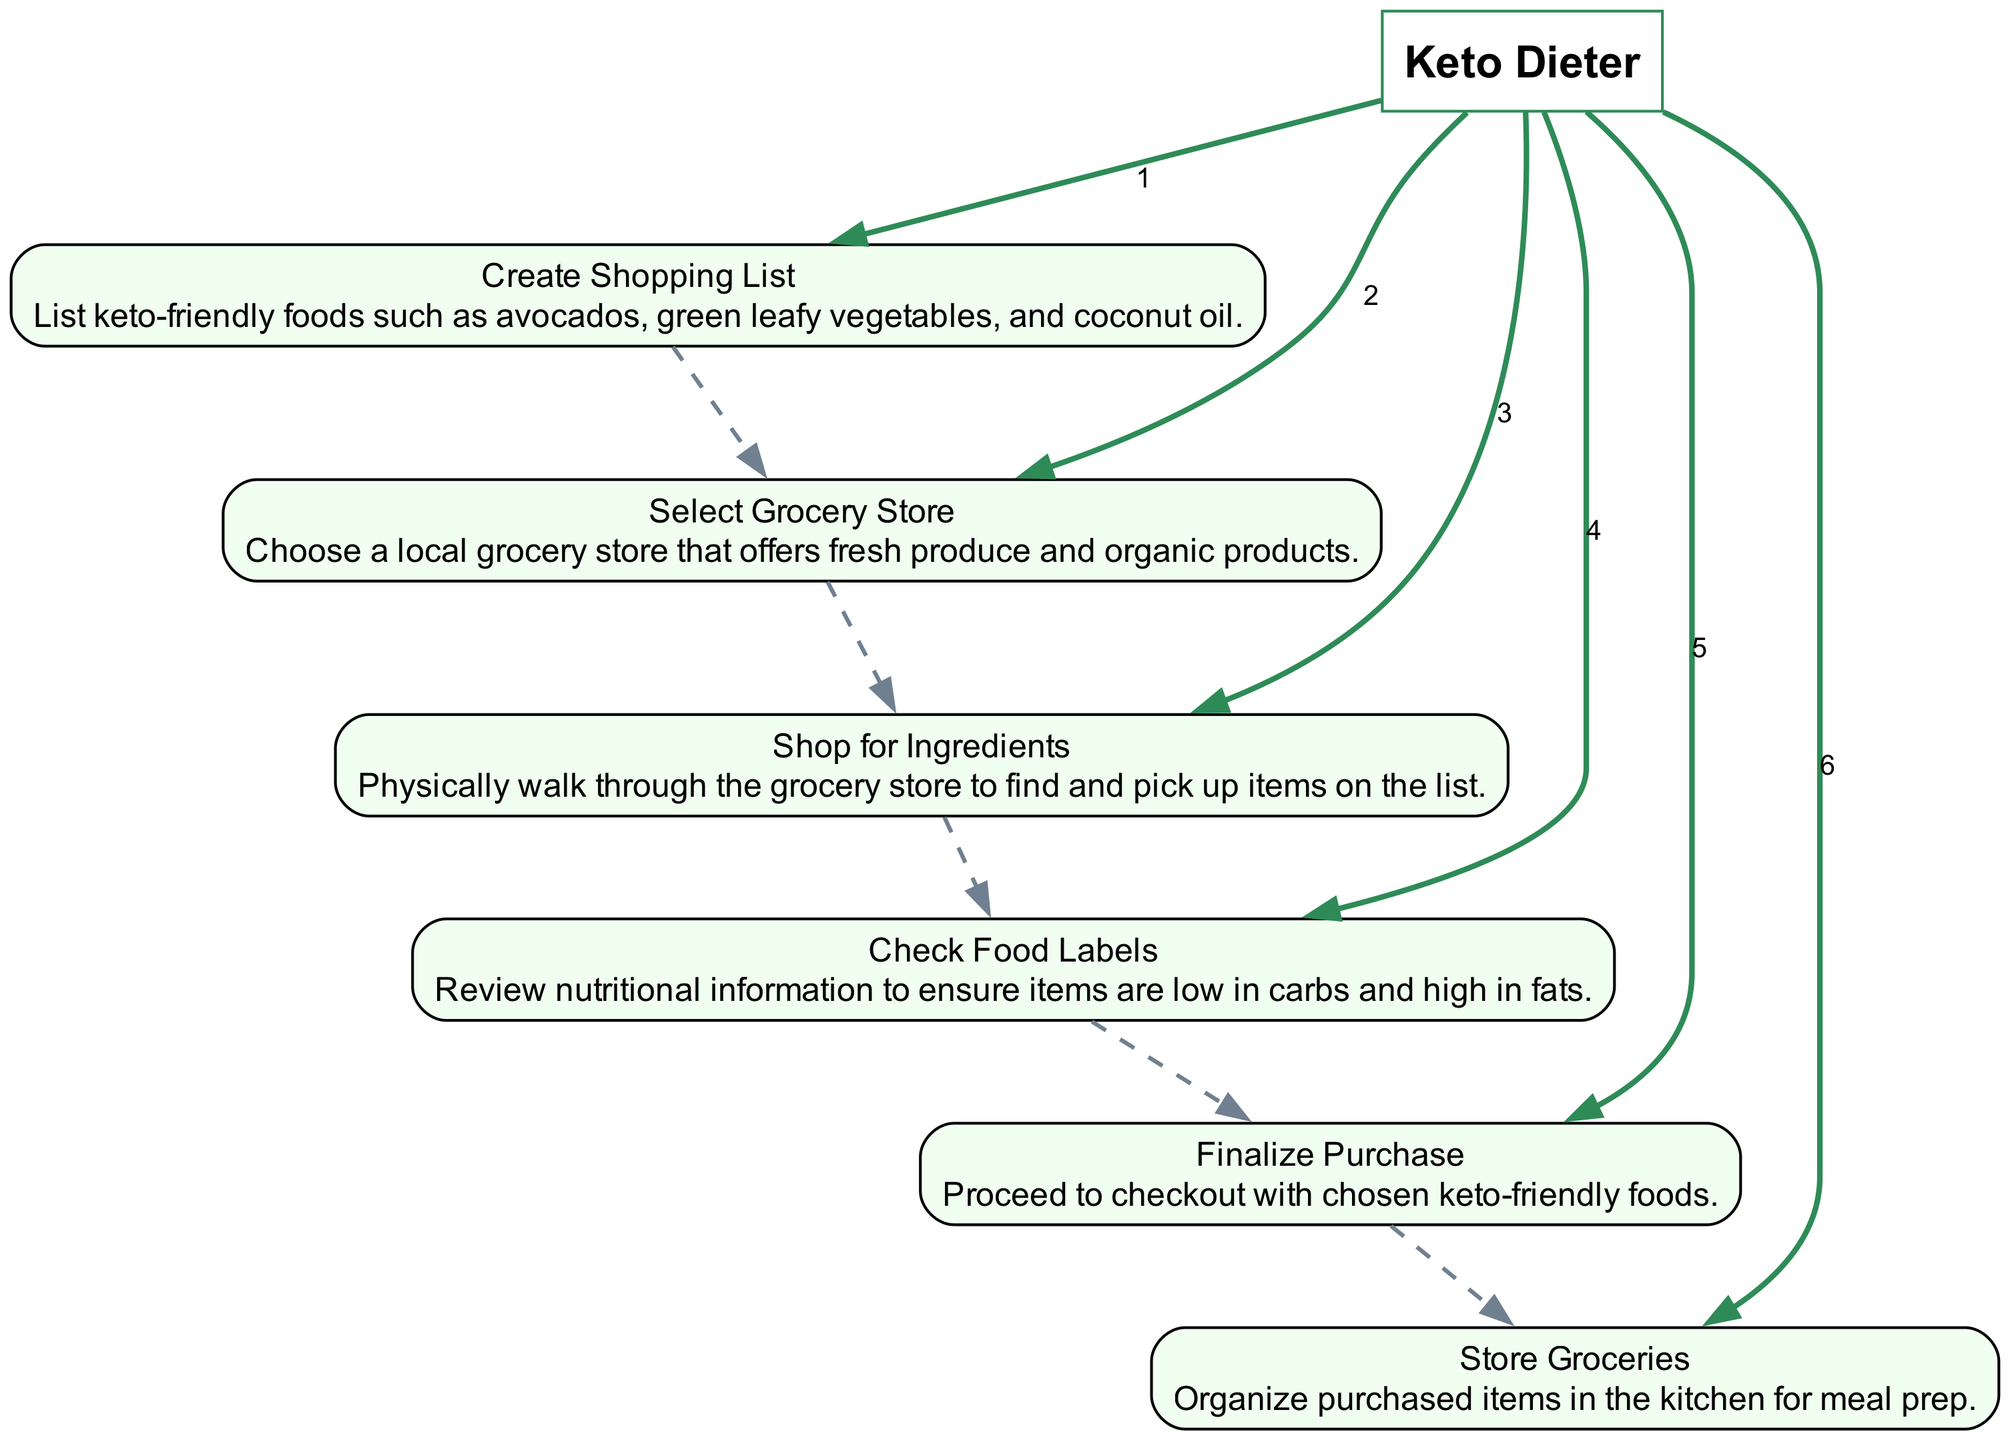What is the first action taken by the Keto Dieter? The first action listed in the diagram is "Create Shopping List," which is the initial step in the sequence of actions.
Answer: Create Shopping List How many actions are there in total? By counting the sequence elements provided, there are six distinct actions represented in the diagram.
Answer: 6 What does the Keto Dieter do after selecting a grocery store? Following the action of selecting a grocery store, the next action is "Shop for Ingredients," indicating the sequence of actions to perform after the store selection.
Answer: Shop for Ingredients Which action involves reviewing nutritional information? The action labeled "Check Food Labels" specifically describes the process of reviewing nutritional information to ensure the food items are suitable for a ketogenic diet.
Answer: Check Food Labels What is the last action in the sequence? The last action outlined in the diagram is "Store Groceries," which signifies the completion of the grocery shopping process.
Answer: Store Groceries Is there a direct connection between "Finalize Purchase" and "Store Groceries"? There is an indirect connection since "Finalize Purchase" precedes "Store Groceries," so after finalizing the purchase, the next step is to store the groceries.
Answer: Yes What type of store does the Keto Dieter choose? The Keto Dieter selects a "local grocery store that offers fresh produce and organic products," indicating the specific type of store preferred for shopping.
Answer: Local grocery store How are the actions connected in the diagram? The actions in the diagram are connected sequentially with directed edges, showing the flow from one action to the next, indicating the order of operations.
Answer: Sequentially Which action comes immediately after "Check Food Labels"? The action that follows "Check Food Labels" is "Finalize Purchase," indicating the steps that follow reviewing the food items.
Answer: Finalize Purchase 